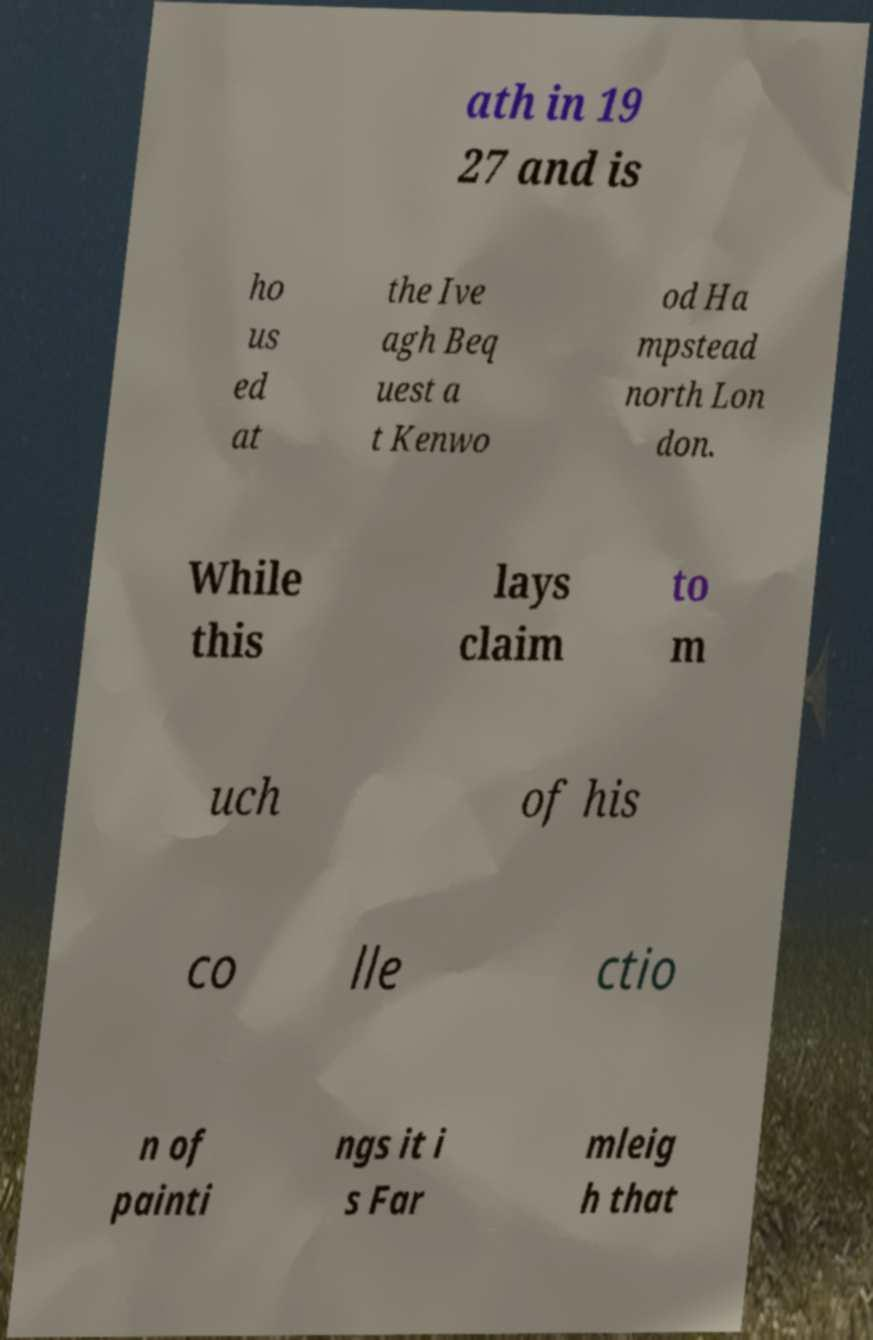I need the written content from this picture converted into text. Can you do that? ath in 19 27 and is ho us ed at the Ive agh Beq uest a t Kenwo od Ha mpstead north Lon don. While this lays claim to m uch of his co lle ctio n of painti ngs it i s Far mleig h that 